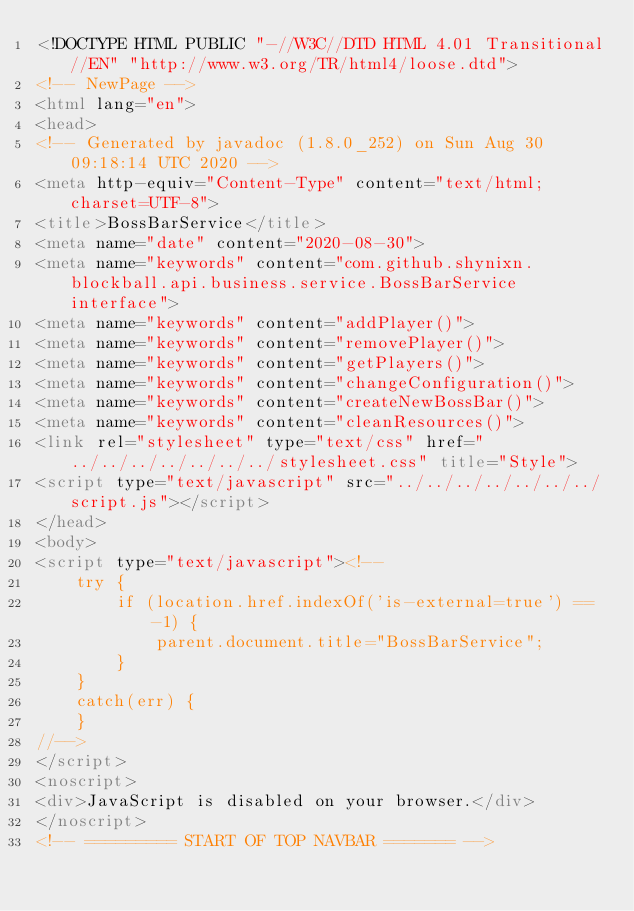<code> <loc_0><loc_0><loc_500><loc_500><_HTML_><!DOCTYPE HTML PUBLIC "-//W3C//DTD HTML 4.01 Transitional//EN" "http://www.w3.org/TR/html4/loose.dtd">
<!-- NewPage -->
<html lang="en">
<head>
<!-- Generated by javadoc (1.8.0_252) on Sun Aug 30 09:18:14 UTC 2020 -->
<meta http-equiv="Content-Type" content="text/html; charset=UTF-8">
<title>BossBarService</title>
<meta name="date" content="2020-08-30">
<meta name="keywords" content="com.github.shynixn.blockball.api.business.service.BossBarService interface">
<meta name="keywords" content="addPlayer()">
<meta name="keywords" content="removePlayer()">
<meta name="keywords" content="getPlayers()">
<meta name="keywords" content="changeConfiguration()">
<meta name="keywords" content="createNewBossBar()">
<meta name="keywords" content="cleanResources()">
<link rel="stylesheet" type="text/css" href="../../../../../../../stylesheet.css" title="Style">
<script type="text/javascript" src="../../../../../../../script.js"></script>
</head>
<body>
<script type="text/javascript"><!--
    try {
        if (location.href.indexOf('is-external=true') == -1) {
            parent.document.title="BossBarService";
        }
    }
    catch(err) {
    }
//-->
</script>
<noscript>
<div>JavaScript is disabled on your browser.</div>
</noscript>
<!-- ========= START OF TOP NAVBAR ======= --></code> 